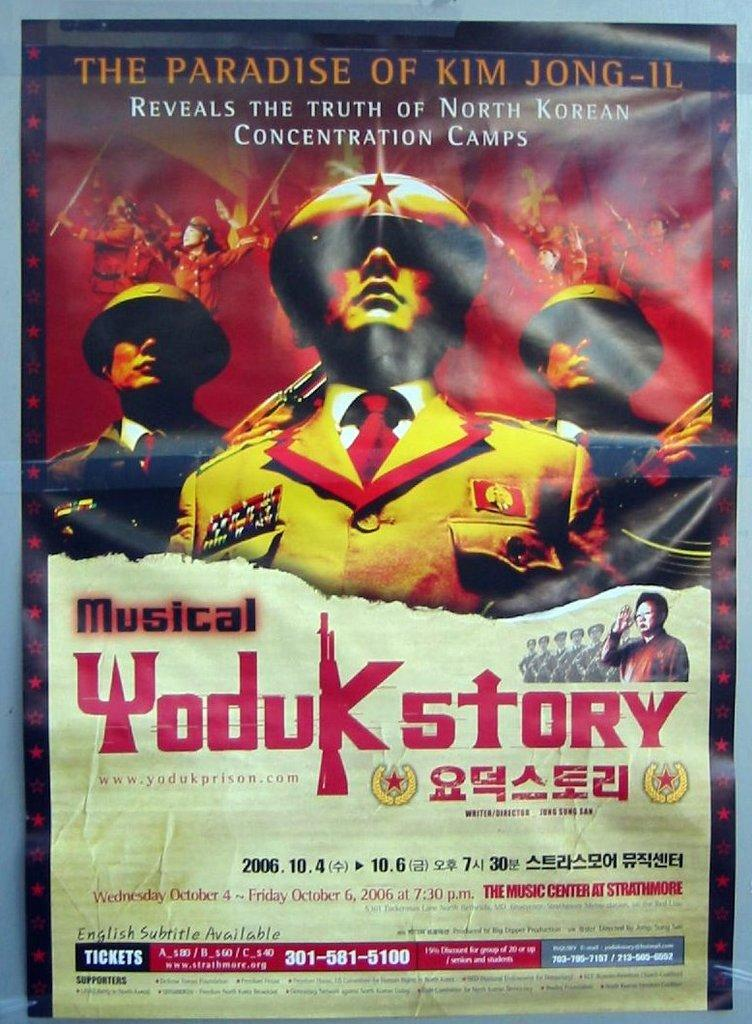<image>
Render a clear and concise summary of the photo. Poster for a musical titled "Yoduk Story" which takes place on October 4th. 